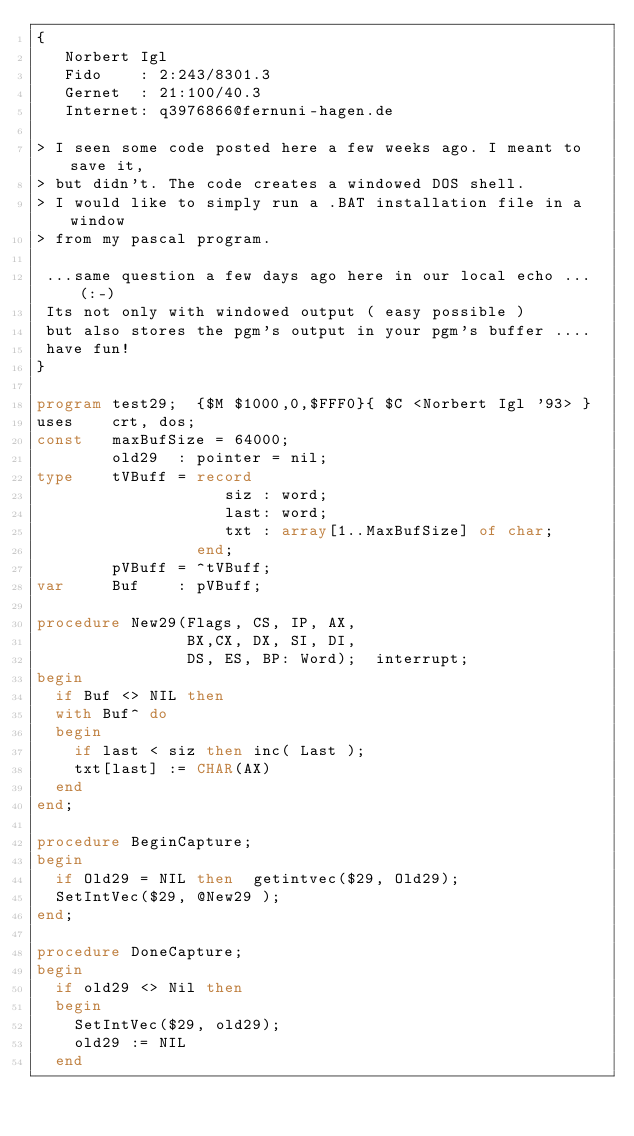<code> <loc_0><loc_0><loc_500><loc_500><_Pascal_>{
   Norbert Igl
   Fido    : 2:243/8301.3
   Gernet  : 21:100/40.3
   Internet: q3976866@fernuni-hagen.de

> I seen some code posted here a few weeks ago. I meant to save it,
> but didn't. The code creates a windowed DOS shell.
> I would like to simply run a .BAT installation file in a window
> from my pascal program.

 ...same question a few days ago here in our local echo ... (:-)
 Its not only with windowed output ( easy possible )
 but also stores the pgm's output in your pgm's buffer ....
 have fun!
}

program test29;  {$M $1000,0,$FFF0}{ $C <Norbert Igl '93> }
uses    crt, dos;
const   maxBufSize = 64000;
        old29  : pointer = nil;
type    tVBuff = record
                    siz : word;
                    last: word;
                    txt : array[1..MaxBufSize] of char;
                 end;
        pVBuff = ^tVBuff;
var     Buf    : pVBuff;

procedure New29(Flags, CS, IP, AX,
                BX,CX, DX, SI, DI,
                DS, ES, BP: Word);  interrupt;
begin
  if Buf <> NIL then
  with Buf^ do
  begin
    if last < siz then inc( Last );
    txt[last] := CHAR(AX)
  end
end;

procedure BeginCapture;
begin
  if Old29 = NIL then  getintvec($29, Old29);
  SetIntVec($29, @New29 );
end;

procedure DoneCapture;
begin
  if old29 <> Nil then
  begin
    SetIntVec($29, old29);
    old29 := NIL
  end</code> 